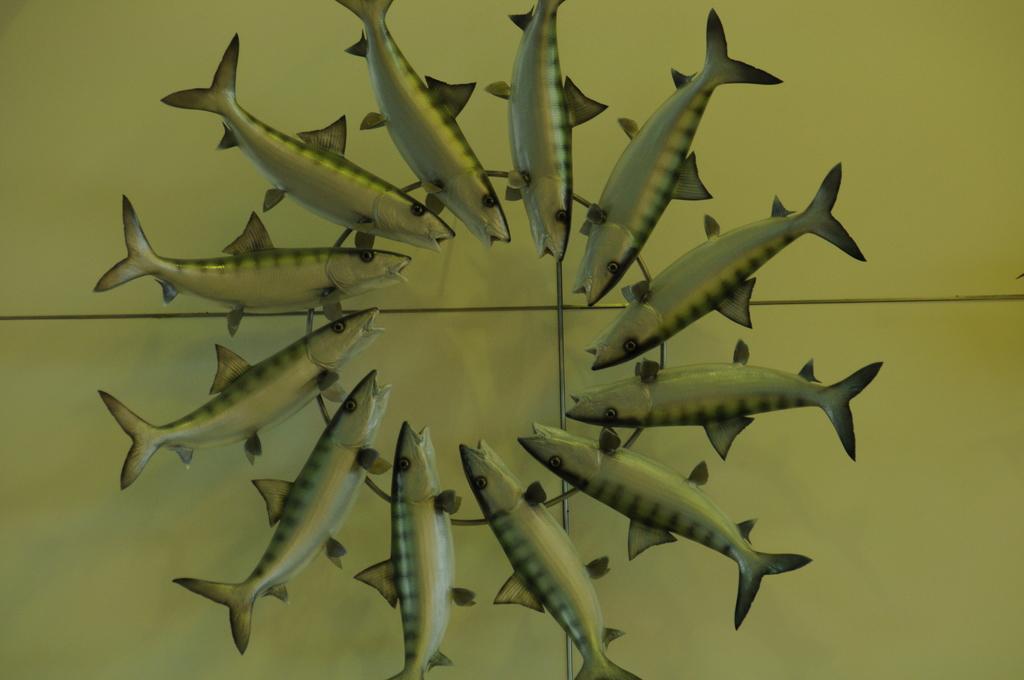In one or two sentences, can you explain what this image depicts? In this picture I can see there are few fishes placed on a surface and it has a tail, fins, eyes and a mouth. 